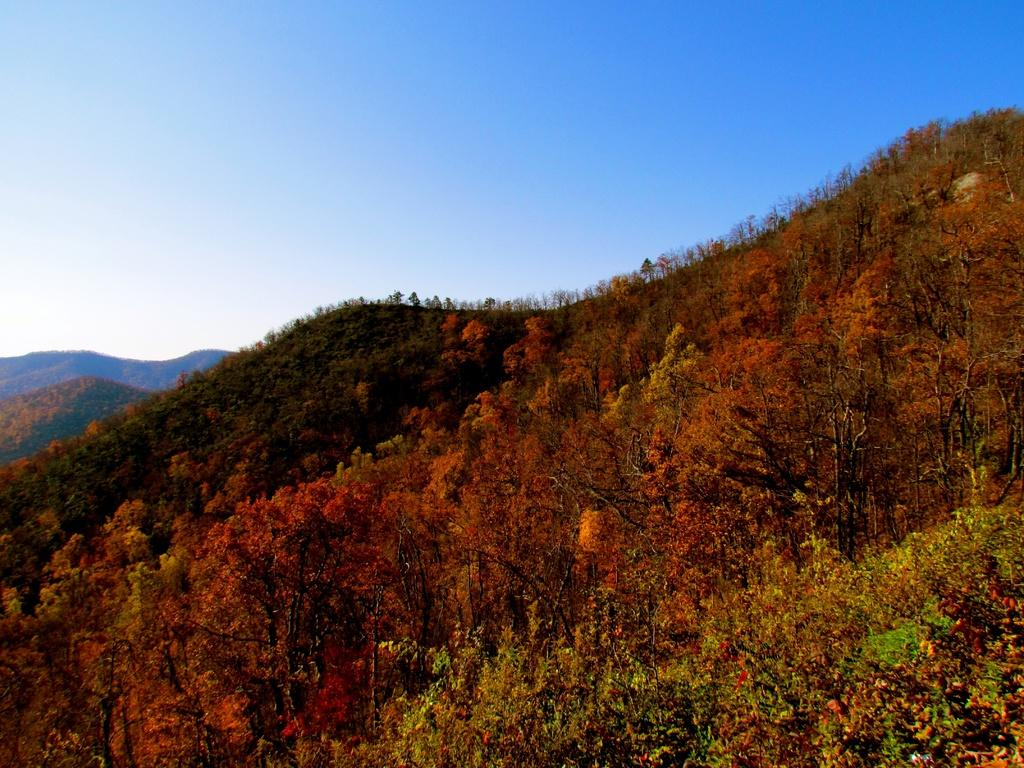What type of vegetation can be seen in the foreground of the image? There are trees on the cliffs in the foreground of the image. What type of geographical feature is visible in the background of the image? There are mountains in the background of the image. What part of the natural environment is visible in the background of the image? The sky is visible in the background of the image. What type of seed is being used to brew tea in the image? There is no kettle or tea-brewing activity present in the image. What is the relation between the trees and the mountains in the image? The trees are located on the cliffs in the foreground, while the mountains are in the background. There is no direct relation between the trees and the mountains in the image. 